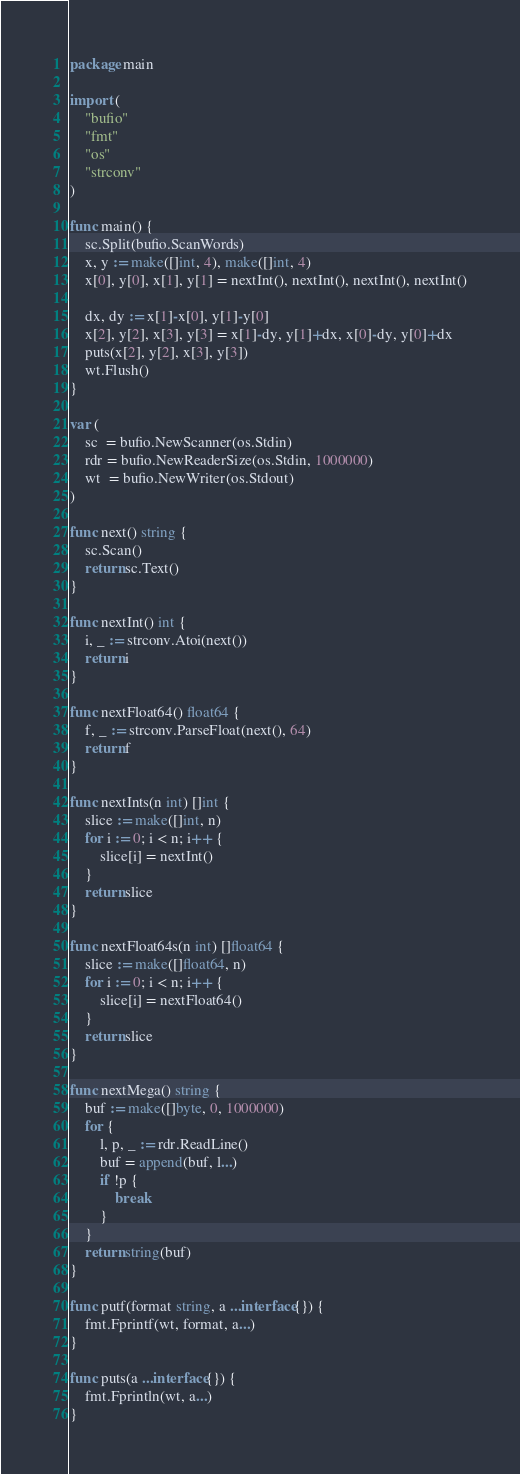<code> <loc_0><loc_0><loc_500><loc_500><_Go_>package main

import (
	"bufio"
	"fmt"
	"os"
	"strconv"
)

func main() {
	sc.Split(bufio.ScanWords)
	x, y := make([]int, 4), make([]int, 4)
	x[0], y[0], x[1], y[1] = nextInt(), nextInt(), nextInt(), nextInt()

	dx, dy := x[1]-x[0], y[1]-y[0]
	x[2], y[2], x[3], y[3] = x[1]-dy, y[1]+dx, x[0]-dy, y[0]+dx
	puts(x[2], y[2], x[3], y[3])
	wt.Flush()
}

var (
	sc  = bufio.NewScanner(os.Stdin)
	rdr = bufio.NewReaderSize(os.Stdin, 1000000)
	wt  = bufio.NewWriter(os.Stdout)
)

func next() string {
	sc.Scan()
	return sc.Text()
}

func nextInt() int {
	i, _ := strconv.Atoi(next())
	return i
}

func nextFloat64() float64 {
	f, _ := strconv.ParseFloat(next(), 64)
	return f
}

func nextInts(n int) []int {
	slice := make([]int, n)
	for i := 0; i < n; i++ {
		slice[i] = nextInt()
	}
	return slice
}

func nextFloat64s(n int) []float64 {
	slice := make([]float64, n)
	for i := 0; i < n; i++ {
		slice[i] = nextFloat64()
	}
	return slice
}

func nextMega() string {
	buf := make([]byte, 0, 1000000)
	for {
		l, p, _ := rdr.ReadLine()
		buf = append(buf, l...)
		if !p {
			break
		}
	}
	return string(buf)
}

func putf(format string, a ...interface{}) {
	fmt.Fprintf(wt, format, a...)
}

func puts(a ...interface{}) {
	fmt.Fprintln(wt, a...)
}
</code> 